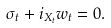Convert formula to latex. <formula><loc_0><loc_0><loc_500><loc_500>\sigma _ { t } + i _ { X _ { t } } w _ { t } = 0 .</formula> 